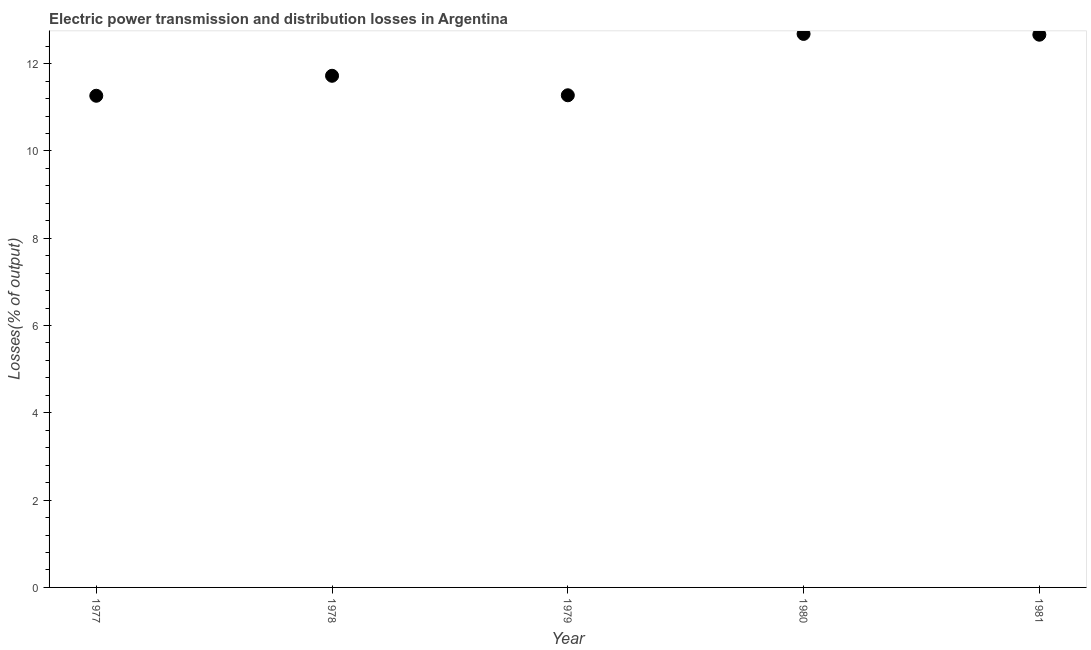What is the electric power transmission and distribution losses in 1981?
Your answer should be compact. 12.66. Across all years, what is the maximum electric power transmission and distribution losses?
Keep it short and to the point. 12.68. Across all years, what is the minimum electric power transmission and distribution losses?
Provide a short and direct response. 11.26. In which year was the electric power transmission and distribution losses minimum?
Provide a succinct answer. 1977. What is the sum of the electric power transmission and distribution losses?
Ensure brevity in your answer.  59.6. What is the difference between the electric power transmission and distribution losses in 1978 and 1980?
Your response must be concise. -0.96. What is the average electric power transmission and distribution losses per year?
Offer a terse response. 11.92. What is the median electric power transmission and distribution losses?
Keep it short and to the point. 11.72. Do a majority of the years between 1978 and 1981 (inclusive) have electric power transmission and distribution losses greater than 5.2 %?
Your answer should be very brief. Yes. What is the ratio of the electric power transmission and distribution losses in 1979 to that in 1980?
Your answer should be very brief. 0.89. Is the electric power transmission and distribution losses in 1979 less than that in 1980?
Your answer should be compact. Yes. Is the difference between the electric power transmission and distribution losses in 1979 and 1981 greater than the difference between any two years?
Make the answer very short. No. What is the difference between the highest and the second highest electric power transmission and distribution losses?
Offer a very short reply. 0.02. What is the difference between the highest and the lowest electric power transmission and distribution losses?
Your answer should be compact. 1.42. In how many years, is the electric power transmission and distribution losses greater than the average electric power transmission and distribution losses taken over all years?
Keep it short and to the point. 2. Does the electric power transmission and distribution losses monotonically increase over the years?
Ensure brevity in your answer.  No. How many dotlines are there?
Keep it short and to the point. 1. How many years are there in the graph?
Your response must be concise. 5. What is the difference between two consecutive major ticks on the Y-axis?
Your response must be concise. 2. Are the values on the major ticks of Y-axis written in scientific E-notation?
Your answer should be very brief. No. What is the title of the graph?
Your response must be concise. Electric power transmission and distribution losses in Argentina. What is the label or title of the X-axis?
Keep it short and to the point. Year. What is the label or title of the Y-axis?
Your answer should be very brief. Losses(% of output). What is the Losses(% of output) in 1977?
Offer a terse response. 11.26. What is the Losses(% of output) in 1978?
Keep it short and to the point. 11.72. What is the Losses(% of output) in 1979?
Keep it short and to the point. 11.27. What is the Losses(% of output) in 1980?
Provide a short and direct response. 12.68. What is the Losses(% of output) in 1981?
Give a very brief answer. 12.66. What is the difference between the Losses(% of output) in 1977 and 1978?
Your answer should be compact. -0.46. What is the difference between the Losses(% of output) in 1977 and 1979?
Your response must be concise. -0.01. What is the difference between the Losses(% of output) in 1977 and 1980?
Keep it short and to the point. -1.42. What is the difference between the Losses(% of output) in 1977 and 1981?
Keep it short and to the point. -1.4. What is the difference between the Losses(% of output) in 1978 and 1979?
Provide a short and direct response. 0.45. What is the difference between the Losses(% of output) in 1978 and 1980?
Your answer should be very brief. -0.96. What is the difference between the Losses(% of output) in 1978 and 1981?
Keep it short and to the point. -0.94. What is the difference between the Losses(% of output) in 1979 and 1980?
Offer a very short reply. -1.41. What is the difference between the Losses(% of output) in 1979 and 1981?
Make the answer very short. -1.39. What is the difference between the Losses(% of output) in 1980 and 1981?
Offer a very short reply. 0.02. What is the ratio of the Losses(% of output) in 1977 to that in 1980?
Ensure brevity in your answer.  0.89. What is the ratio of the Losses(% of output) in 1977 to that in 1981?
Your answer should be very brief. 0.89. What is the ratio of the Losses(% of output) in 1978 to that in 1979?
Provide a succinct answer. 1.04. What is the ratio of the Losses(% of output) in 1978 to that in 1980?
Offer a very short reply. 0.92. What is the ratio of the Losses(% of output) in 1978 to that in 1981?
Your answer should be compact. 0.93. What is the ratio of the Losses(% of output) in 1979 to that in 1980?
Offer a terse response. 0.89. What is the ratio of the Losses(% of output) in 1979 to that in 1981?
Provide a short and direct response. 0.89. 